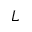<formula> <loc_0><loc_0><loc_500><loc_500>L</formula> 